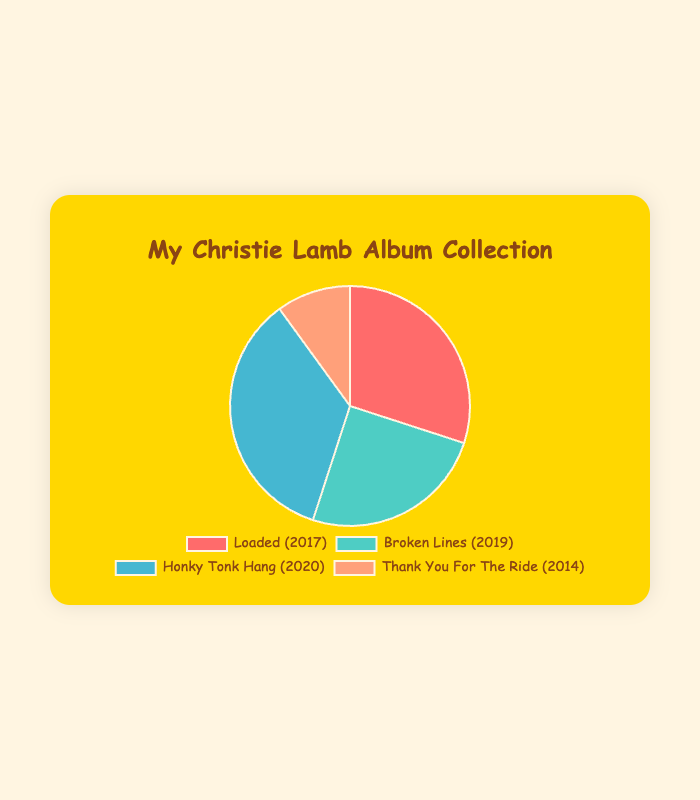Which album comprises the largest portion of the collection? By looking at the pie chart, the largest slice corresponds to the album "Honky Tonk Hang," which is 35% of the collection. This means it is the largest portion.
Answer: Honky Tonk Hang Which album has the smallest percentage in the collection, and what is its percentage? The smallest slice on the pie chart corresponds to the album "Thank You For The Ride," which is 10%.
Answer: Thank You For The Ride, 10% How does the percentage of "Broken Lines" compare to "Loaded"? "Broken Lines" makes up 25% of the collection, while "Loaded" is 30%. Thus, "Loaded" has a higher percentage compared to "Broken Lines."
Answer: Loaded has a higher percentage How many more tracks are in "Honky Tonk Hang" compared to "Thank You For The Ride"? "Honky Tonk Hang" has 14 tracks, while "Thank You For The Ride" has 9 tracks. Subtracting the latter from the former, 14 - 9 = 5 tracks.
Answer: 5 tracks By how much does the percentage of "Honky Tonk Hang" exceed "Broken Lines"? "Honky Tonk Hang" is 35% and "Broken Lines" is 25%. The difference is 35% - 25% = 10%.
Answer: 10% What is the total percentage of "Loaded" and "Broken Lines" combined? "Loaded" is 30% and "Broken Lines" is 25%. Adding them together, 30% + 25% = 55%.
Answer: 55% If "Broken Lines" had 5% more, would it surpass "Loaded" in percentage? "Broken Lines" is currently 25%. Adding 5% would make it 30%, which is equal to "Loaded." Hence, it would not surpass but would be equal to "Loaded."
Answer: No, they would be equal Which album is represented by the blue slice? Based on the color coding of the pie chart, the blue slice represents "Honky Tonk Hang."
Answer: Honky Tonk Hang What are the total tracks from "Loaded" and "Broken Lines" combined? "Loaded" has 12 tracks and "Broken Lines" has 10 tracks. Adding them together, 12 + 10 = 22 tracks.
Answer: 22 tracks Is there any album released before 2015 and what is its share in the collection? "Thank You For The Ride" was released in 2014, and it constitutes 10% of the collection.
Answer: Yes, 10% 